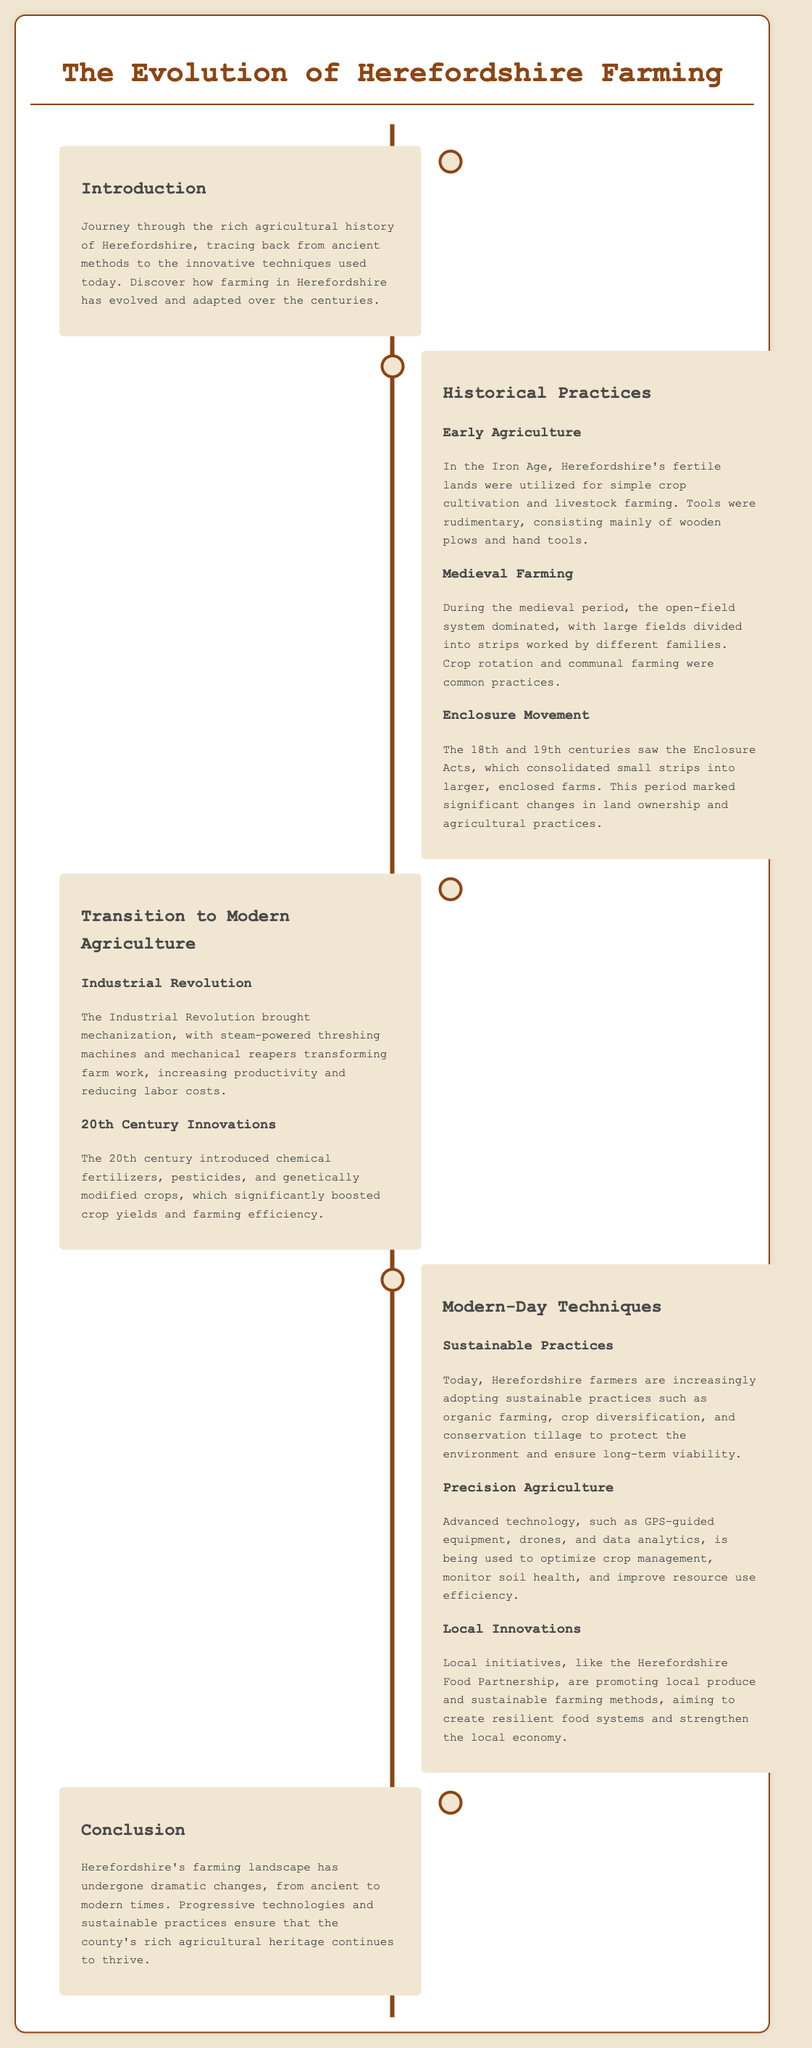what period saw the Enclosure Acts? The Enclosure Acts were significant changes in land ownership and agricultural practices during the 18th and 19th centuries.
Answer: 18th and 19th centuries what farming method used in the Iron Age? The Iron Age utilized simple crop cultivation and livestock farming with rudimentary tools.
Answer: Simple crop cultivation and livestock farming which revolution brought mechanization to farming? The Industrial Revolution introduced mechanization in farming, transforming farm work.
Answer: Industrial Revolution what technique is increasingly adopted by modern Herefordshire farmers? Modern farmers are adopting sustainable practices to protect the environment and ensure long-term viability.
Answer: Sustainable practices what does GPS in precision agriculture mean? GPS is used in precision agriculture to optimize crop management and improve resource use efficiency.
Answer: GPS which partnership promotes local produce in Herefordshire? The Herefordshire Food Partnership aims to promote local produce and sustainable farming methods.
Answer: Herefordshire Food Partnership what aspect of traditional farming was common during the medieval period? During the medieval period, crop rotation and communal farming were common practices.
Answer: Crop rotation and communal farming what is one technological advancement mentioned? Advanced technology includes the use of drones in farming for monitoring and optimization.
Answer: Drones what is the conclusion about Herefordshire's agricultural changes? The document concludes that Herefordshire's farming landscape has undergone dramatic changes ensuring the county's agricultural heritage continues to thrive.
Answer: Dramatic changes 